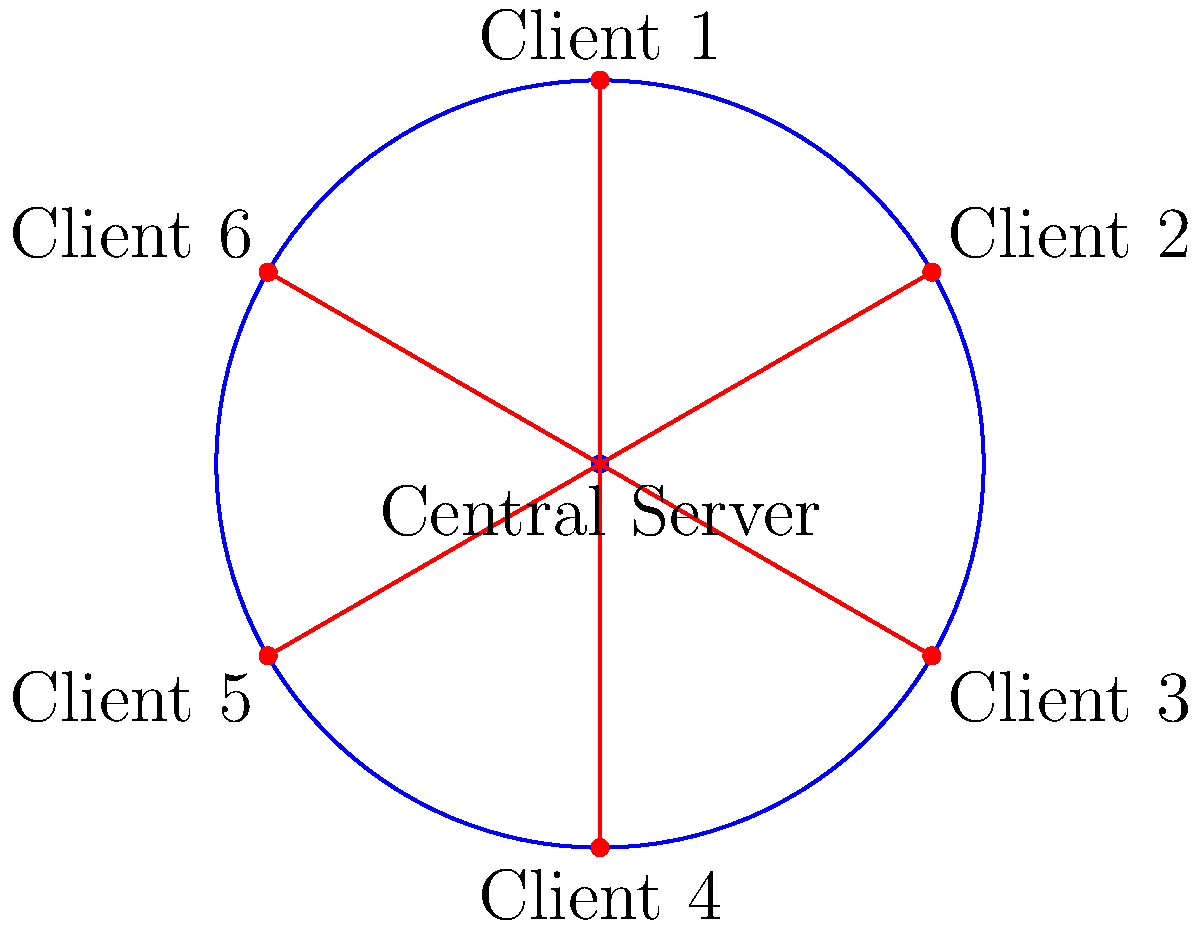In a star topology for a centralized patient records database, if the central server experiences a failure, what percentage of the network's functionality is lost? To determine the percentage of network functionality lost when the central server fails in a star topology, we need to consider the following steps:

1. Understand the star topology: In this configuration, all clients (nodes) are connected directly to a central server.

2. Analyze the central server's role: The central server acts as a hub for all communication and data transfer between clients.

3. Consider the impact of central server failure:
   a. No client can communicate with any other client.
   b. No client can access the centralized patient records database.
   c. All data transfer and communication within the network cease.

4. Calculate the percentage of functionality lost:
   - Since all network operations depend on the central server, its failure results in a complete loss of network functionality.
   - This means 100% of the network's functionality is lost.

5. Consider the implications for patient data:
   - No access to patient records
   - Inability to update or retrieve critical medical information
   - Potential risks to patient care and privacy

Therefore, in a star topology for a centralized patient records database, a central server failure results in a 100% loss of network functionality, highlighting the critical importance of robust security measures and backup systems in healthcare IT infrastructure.
Answer: 100% 